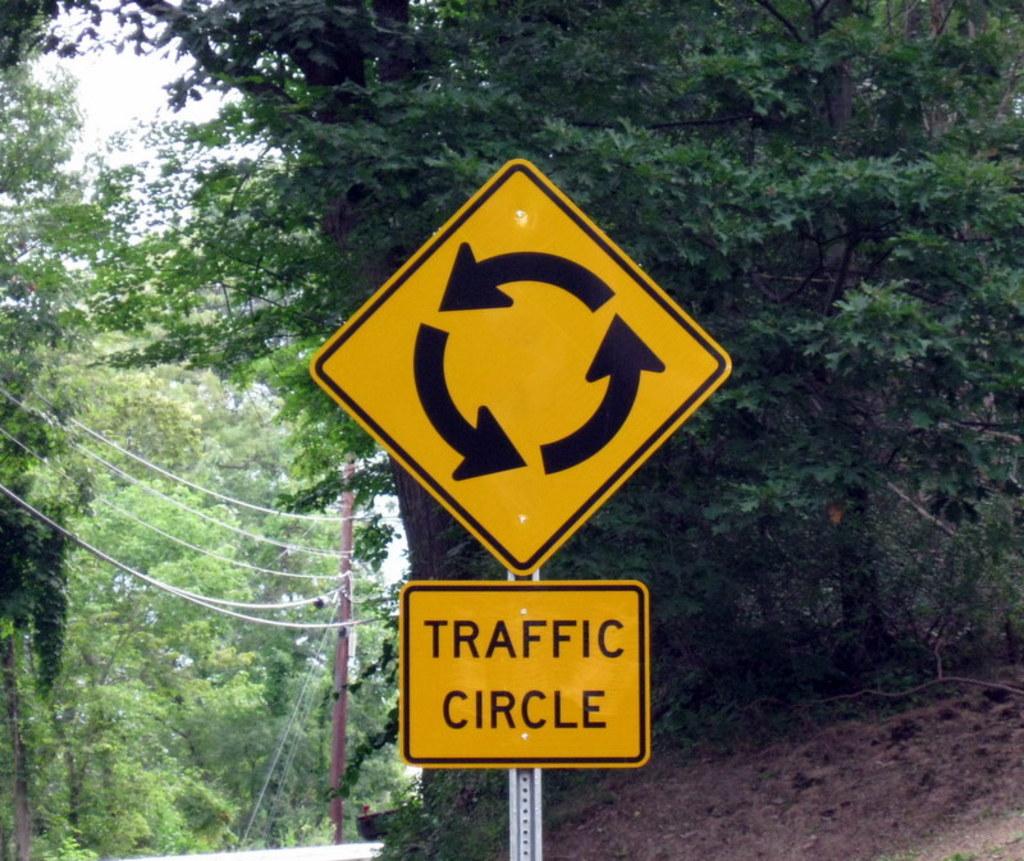What kind of circle is the sign for?
Give a very brief answer. Traffic. What does this sign warn drivers of?
Your answer should be very brief. Traffic circle. 